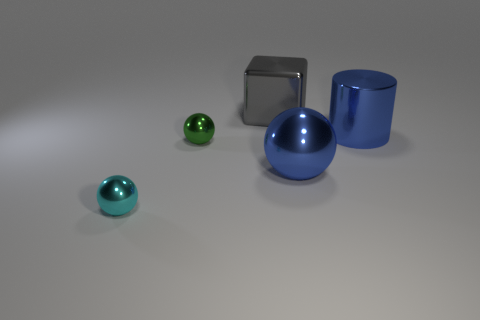Subtract all gray balls. Subtract all blue blocks. How many balls are left? 3 Add 1 big cyan rubber cylinders. How many objects exist? 6 Subtract all spheres. How many objects are left? 2 Add 2 blue shiny spheres. How many blue shiny spheres are left? 3 Add 2 purple blocks. How many purple blocks exist? 2 Subtract 0 red balls. How many objects are left? 5 Subtract all big objects. Subtract all tiny red matte objects. How many objects are left? 2 